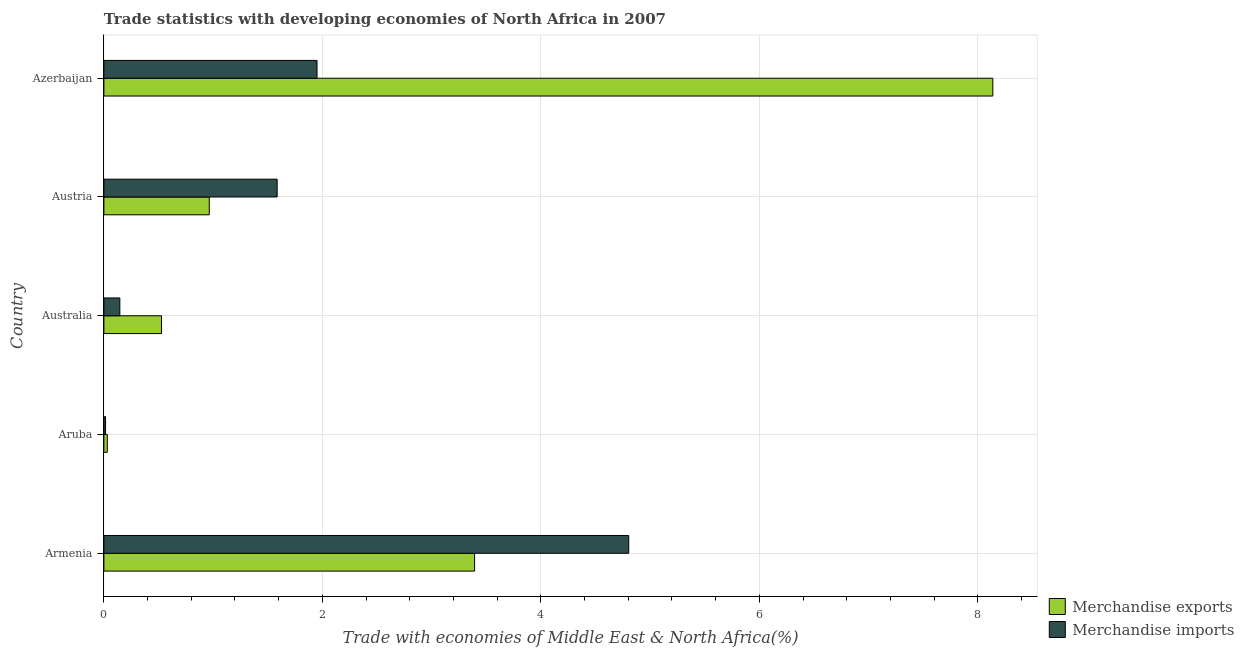Are the number of bars per tick equal to the number of legend labels?
Your response must be concise. Yes. How many bars are there on the 4th tick from the bottom?
Provide a succinct answer. 2. What is the merchandise imports in Austria?
Your answer should be very brief. 1.59. Across all countries, what is the maximum merchandise imports?
Your answer should be compact. 4.8. Across all countries, what is the minimum merchandise imports?
Offer a very short reply. 0.02. In which country was the merchandise imports maximum?
Provide a short and direct response. Armenia. In which country was the merchandise exports minimum?
Give a very brief answer. Aruba. What is the total merchandise imports in the graph?
Provide a succinct answer. 8.5. What is the difference between the merchandise exports in Aruba and that in Austria?
Offer a very short reply. -0.93. What is the difference between the merchandise imports in Australia and the merchandise exports in Austria?
Provide a succinct answer. -0.82. What is the average merchandise imports per country?
Your answer should be very brief. 1.7. What is the difference between the merchandise imports and merchandise exports in Armenia?
Your answer should be very brief. 1.41. What is the ratio of the merchandise imports in Aruba to that in Azerbaijan?
Your response must be concise. 0.01. Is the difference between the merchandise imports in Aruba and Austria greater than the difference between the merchandise exports in Aruba and Austria?
Provide a succinct answer. No. What is the difference between the highest and the second highest merchandise imports?
Provide a succinct answer. 2.85. What is the difference between the highest and the lowest merchandise exports?
Keep it short and to the point. 8.11. In how many countries, is the merchandise exports greater than the average merchandise exports taken over all countries?
Offer a terse response. 2. How many bars are there?
Ensure brevity in your answer.  10. Are all the bars in the graph horizontal?
Keep it short and to the point. Yes. How many countries are there in the graph?
Your response must be concise. 5. Where does the legend appear in the graph?
Make the answer very short. Bottom right. How many legend labels are there?
Ensure brevity in your answer.  2. How are the legend labels stacked?
Your response must be concise. Vertical. What is the title of the graph?
Your response must be concise. Trade statistics with developing economies of North Africa in 2007. Does "GDP" appear as one of the legend labels in the graph?
Offer a terse response. No. What is the label or title of the X-axis?
Provide a short and direct response. Trade with economies of Middle East & North Africa(%). What is the label or title of the Y-axis?
Ensure brevity in your answer.  Country. What is the Trade with economies of Middle East & North Africa(%) in Merchandise exports in Armenia?
Offer a very short reply. 3.39. What is the Trade with economies of Middle East & North Africa(%) of Merchandise imports in Armenia?
Offer a terse response. 4.8. What is the Trade with economies of Middle East & North Africa(%) in Merchandise exports in Aruba?
Your answer should be compact. 0.03. What is the Trade with economies of Middle East & North Africa(%) in Merchandise imports in Aruba?
Provide a short and direct response. 0.02. What is the Trade with economies of Middle East & North Africa(%) in Merchandise exports in Australia?
Give a very brief answer. 0.53. What is the Trade with economies of Middle East & North Africa(%) of Merchandise imports in Australia?
Your answer should be compact. 0.15. What is the Trade with economies of Middle East & North Africa(%) in Merchandise exports in Austria?
Your answer should be compact. 0.96. What is the Trade with economies of Middle East & North Africa(%) of Merchandise imports in Austria?
Ensure brevity in your answer.  1.59. What is the Trade with economies of Middle East & North Africa(%) of Merchandise exports in Azerbaijan?
Keep it short and to the point. 8.14. What is the Trade with economies of Middle East & North Africa(%) in Merchandise imports in Azerbaijan?
Provide a short and direct response. 1.95. Across all countries, what is the maximum Trade with economies of Middle East & North Africa(%) of Merchandise exports?
Ensure brevity in your answer.  8.14. Across all countries, what is the maximum Trade with economies of Middle East & North Africa(%) of Merchandise imports?
Your response must be concise. 4.8. Across all countries, what is the minimum Trade with economies of Middle East & North Africa(%) of Merchandise exports?
Keep it short and to the point. 0.03. Across all countries, what is the minimum Trade with economies of Middle East & North Africa(%) in Merchandise imports?
Your response must be concise. 0.02. What is the total Trade with economies of Middle East & North Africa(%) in Merchandise exports in the graph?
Your response must be concise. 13.05. What is the total Trade with economies of Middle East & North Africa(%) of Merchandise imports in the graph?
Offer a terse response. 8.5. What is the difference between the Trade with economies of Middle East & North Africa(%) of Merchandise exports in Armenia and that in Aruba?
Your answer should be compact. 3.36. What is the difference between the Trade with economies of Middle East & North Africa(%) of Merchandise imports in Armenia and that in Aruba?
Provide a short and direct response. 4.79. What is the difference between the Trade with economies of Middle East & North Africa(%) in Merchandise exports in Armenia and that in Australia?
Ensure brevity in your answer.  2.87. What is the difference between the Trade with economies of Middle East & North Africa(%) of Merchandise imports in Armenia and that in Australia?
Provide a succinct answer. 4.66. What is the difference between the Trade with economies of Middle East & North Africa(%) of Merchandise exports in Armenia and that in Austria?
Keep it short and to the point. 2.43. What is the difference between the Trade with economies of Middle East & North Africa(%) in Merchandise imports in Armenia and that in Austria?
Provide a short and direct response. 3.22. What is the difference between the Trade with economies of Middle East & North Africa(%) of Merchandise exports in Armenia and that in Azerbaijan?
Keep it short and to the point. -4.74. What is the difference between the Trade with economies of Middle East & North Africa(%) in Merchandise imports in Armenia and that in Azerbaijan?
Provide a short and direct response. 2.85. What is the difference between the Trade with economies of Middle East & North Africa(%) of Merchandise exports in Aruba and that in Australia?
Offer a very short reply. -0.5. What is the difference between the Trade with economies of Middle East & North Africa(%) in Merchandise imports in Aruba and that in Australia?
Provide a short and direct response. -0.13. What is the difference between the Trade with economies of Middle East & North Africa(%) of Merchandise exports in Aruba and that in Austria?
Provide a short and direct response. -0.93. What is the difference between the Trade with economies of Middle East & North Africa(%) in Merchandise imports in Aruba and that in Austria?
Offer a terse response. -1.57. What is the difference between the Trade with economies of Middle East & North Africa(%) of Merchandise exports in Aruba and that in Azerbaijan?
Make the answer very short. -8.11. What is the difference between the Trade with economies of Middle East & North Africa(%) of Merchandise imports in Aruba and that in Azerbaijan?
Make the answer very short. -1.94. What is the difference between the Trade with economies of Middle East & North Africa(%) in Merchandise exports in Australia and that in Austria?
Make the answer very short. -0.44. What is the difference between the Trade with economies of Middle East & North Africa(%) of Merchandise imports in Australia and that in Austria?
Your answer should be compact. -1.44. What is the difference between the Trade with economies of Middle East & North Africa(%) in Merchandise exports in Australia and that in Azerbaijan?
Make the answer very short. -7.61. What is the difference between the Trade with economies of Middle East & North Africa(%) in Merchandise imports in Australia and that in Azerbaijan?
Your response must be concise. -1.81. What is the difference between the Trade with economies of Middle East & North Africa(%) in Merchandise exports in Austria and that in Azerbaijan?
Offer a very short reply. -7.17. What is the difference between the Trade with economies of Middle East & North Africa(%) of Merchandise imports in Austria and that in Azerbaijan?
Your answer should be very brief. -0.37. What is the difference between the Trade with economies of Middle East & North Africa(%) of Merchandise exports in Armenia and the Trade with economies of Middle East & North Africa(%) of Merchandise imports in Aruba?
Your response must be concise. 3.38. What is the difference between the Trade with economies of Middle East & North Africa(%) of Merchandise exports in Armenia and the Trade with economies of Middle East & North Africa(%) of Merchandise imports in Australia?
Ensure brevity in your answer.  3.25. What is the difference between the Trade with economies of Middle East & North Africa(%) of Merchandise exports in Armenia and the Trade with economies of Middle East & North Africa(%) of Merchandise imports in Austria?
Offer a very short reply. 1.81. What is the difference between the Trade with economies of Middle East & North Africa(%) in Merchandise exports in Armenia and the Trade with economies of Middle East & North Africa(%) in Merchandise imports in Azerbaijan?
Your answer should be compact. 1.44. What is the difference between the Trade with economies of Middle East & North Africa(%) in Merchandise exports in Aruba and the Trade with economies of Middle East & North Africa(%) in Merchandise imports in Australia?
Provide a short and direct response. -0.11. What is the difference between the Trade with economies of Middle East & North Africa(%) of Merchandise exports in Aruba and the Trade with economies of Middle East & North Africa(%) of Merchandise imports in Austria?
Your answer should be compact. -1.55. What is the difference between the Trade with economies of Middle East & North Africa(%) of Merchandise exports in Aruba and the Trade with economies of Middle East & North Africa(%) of Merchandise imports in Azerbaijan?
Give a very brief answer. -1.92. What is the difference between the Trade with economies of Middle East & North Africa(%) of Merchandise exports in Australia and the Trade with economies of Middle East & North Africa(%) of Merchandise imports in Austria?
Your answer should be very brief. -1.06. What is the difference between the Trade with economies of Middle East & North Africa(%) of Merchandise exports in Australia and the Trade with economies of Middle East & North Africa(%) of Merchandise imports in Azerbaijan?
Your response must be concise. -1.42. What is the difference between the Trade with economies of Middle East & North Africa(%) in Merchandise exports in Austria and the Trade with economies of Middle East & North Africa(%) in Merchandise imports in Azerbaijan?
Give a very brief answer. -0.99. What is the average Trade with economies of Middle East & North Africa(%) of Merchandise exports per country?
Ensure brevity in your answer.  2.61. What is the average Trade with economies of Middle East & North Africa(%) of Merchandise imports per country?
Provide a succinct answer. 1.7. What is the difference between the Trade with economies of Middle East & North Africa(%) of Merchandise exports and Trade with economies of Middle East & North Africa(%) of Merchandise imports in Armenia?
Your answer should be very brief. -1.41. What is the difference between the Trade with economies of Middle East & North Africa(%) in Merchandise exports and Trade with economies of Middle East & North Africa(%) in Merchandise imports in Aruba?
Offer a terse response. 0.02. What is the difference between the Trade with economies of Middle East & North Africa(%) of Merchandise exports and Trade with economies of Middle East & North Africa(%) of Merchandise imports in Australia?
Your answer should be very brief. 0.38. What is the difference between the Trade with economies of Middle East & North Africa(%) in Merchandise exports and Trade with economies of Middle East & North Africa(%) in Merchandise imports in Austria?
Offer a very short reply. -0.62. What is the difference between the Trade with economies of Middle East & North Africa(%) in Merchandise exports and Trade with economies of Middle East & North Africa(%) in Merchandise imports in Azerbaijan?
Make the answer very short. 6.19. What is the ratio of the Trade with economies of Middle East & North Africa(%) in Merchandise exports in Armenia to that in Aruba?
Ensure brevity in your answer.  108.75. What is the ratio of the Trade with economies of Middle East & North Africa(%) in Merchandise imports in Armenia to that in Aruba?
Offer a very short reply. 316.75. What is the ratio of the Trade with economies of Middle East & North Africa(%) in Merchandise exports in Armenia to that in Australia?
Provide a short and direct response. 6.43. What is the ratio of the Trade with economies of Middle East & North Africa(%) of Merchandise imports in Armenia to that in Australia?
Offer a terse response. 32.9. What is the ratio of the Trade with economies of Middle East & North Africa(%) of Merchandise exports in Armenia to that in Austria?
Provide a short and direct response. 3.52. What is the ratio of the Trade with economies of Middle East & North Africa(%) in Merchandise imports in Armenia to that in Austria?
Make the answer very short. 3.03. What is the ratio of the Trade with economies of Middle East & North Africa(%) of Merchandise exports in Armenia to that in Azerbaijan?
Ensure brevity in your answer.  0.42. What is the ratio of the Trade with economies of Middle East & North Africa(%) of Merchandise imports in Armenia to that in Azerbaijan?
Provide a succinct answer. 2.46. What is the ratio of the Trade with economies of Middle East & North Africa(%) in Merchandise exports in Aruba to that in Australia?
Offer a very short reply. 0.06. What is the ratio of the Trade with economies of Middle East & North Africa(%) in Merchandise imports in Aruba to that in Australia?
Keep it short and to the point. 0.1. What is the ratio of the Trade with economies of Middle East & North Africa(%) of Merchandise exports in Aruba to that in Austria?
Offer a terse response. 0.03. What is the ratio of the Trade with economies of Middle East & North Africa(%) in Merchandise imports in Aruba to that in Austria?
Your answer should be compact. 0.01. What is the ratio of the Trade with economies of Middle East & North Africa(%) in Merchandise exports in Aruba to that in Azerbaijan?
Offer a very short reply. 0. What is the ratio of the Trade with economies of Middle East & North Africa(%) in Merchandise imports in Aruba to that in Azerbaijan?
Ensure brevity in your answer.  0.01. What is the ratio of the Trade with economies of Middle East & North Africa(%) in Merchandise exports in Australia to that in Austria?
Ensure brevity in your answer.  0.55. What is the ratio of the Trade with economies of Middle East & North Africa(%) in Merchandise imports in Australia to that in Austria?
Keep it short and to the point. 0.09. What is the ratio of the Trade with economies of Middle East & North Africa(%) in Merchandise exports in Australia to that in Azerbaijan?
Provide a succinct answer. 0.06. What is the ratio of the Trade with economies of Middle East & North Africa(%) in Merchandise imports in Australia to that in Azerbaijan?
Give a very brief answer. 0.07. What is the ratio of the Trade with economies of Middle East & North Africa(%) of Merchandise exports in Austria to that in Azerbaijan?
Your answer should be very brief. 0.12. What is the ratio of the Trade with economies of Middle East & North Africa(%) of Merchandise imports in Austria to that in Azerbaijan?
Keep it short and to the point. 0.81. What is the difference between the highest and the second highest Trade with economies of Middle East & North Africa(%) of Merchandise exports?
Ensure brevity in your answer.  4.74. What is the difference between the highest and the second highest Trade with economies of Middle East & North Africa(%) in Merchandise imports?
Offer a very short reply. 2.85. What is the difference between the highest and the lowest Trade with economies of Middle East & North Africa(%) of Merchandise exports?
Keep it short and to the point. 8.11. What is the difference between the highest and the lowest Trade with economies of Middle East & North Africa(%) in Merchandise imports?
Ensure brevity in your answer.  4.79. 